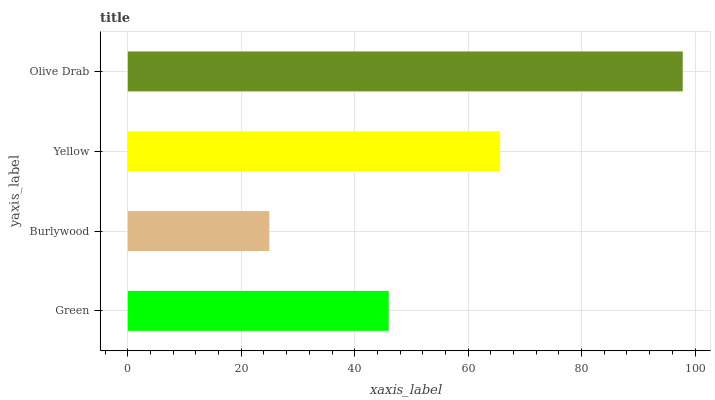Is Burlywood the minimum?
Answer yes or no. Yes. Is Olive Drab the maximum?
Answer yes or no. Yes. Is Yellow the minimum?
Answer yes or no. No. Is Yellow the maximum?
Answer yes or no. No. Is Yellow greater than Burlywood?
Answer yes or no. Yes. Is Burlywood less than Yellow?
Answer yes or no. Yes. Is Burlywood greater than Yellow?
Answer yes or no. No. Is Yellow less than Burlywood?
Answer yes or no. No. Is Yellow the high median?
Answer yes or no. Yes. Is Green the low median?
Answer yes or no. Yes. Is Green the high median?
Answer yes or no. No. Is Olive Drab the low median?
Answer yes or no. No. 